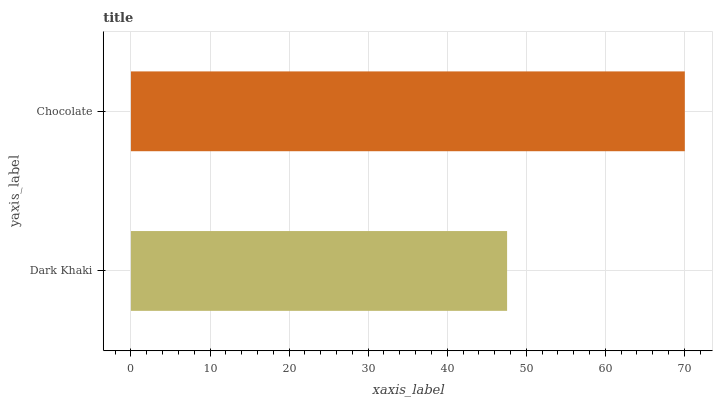Is Dark Khaki the minimum?
Answer yes or no. Yes. Is Chocolate the maximum?
Answer yes or no. Yes. Is Chocolate the minimum?
Answer yes or no. No. Is Chocolate greater than Dark Khaki?
Answer yes or no. Yes. Is Dark Khaki less than Chocolate?
Answer yes or no. Yes. Is Dark Khaki greater than Chocolate?
Answer yes or no. No. Is Chocolate less than Dark Khaki?
Answer yes or no. No. Is Chocolate the high median?
Answer yes or no. Yes. Is Dark Khaki the low median?
Answer yes or no. Yes. Is Dark Khaki the high median?
Answer yes or no. No. Is Chocolate the low median?
Answer yes or no. No. 